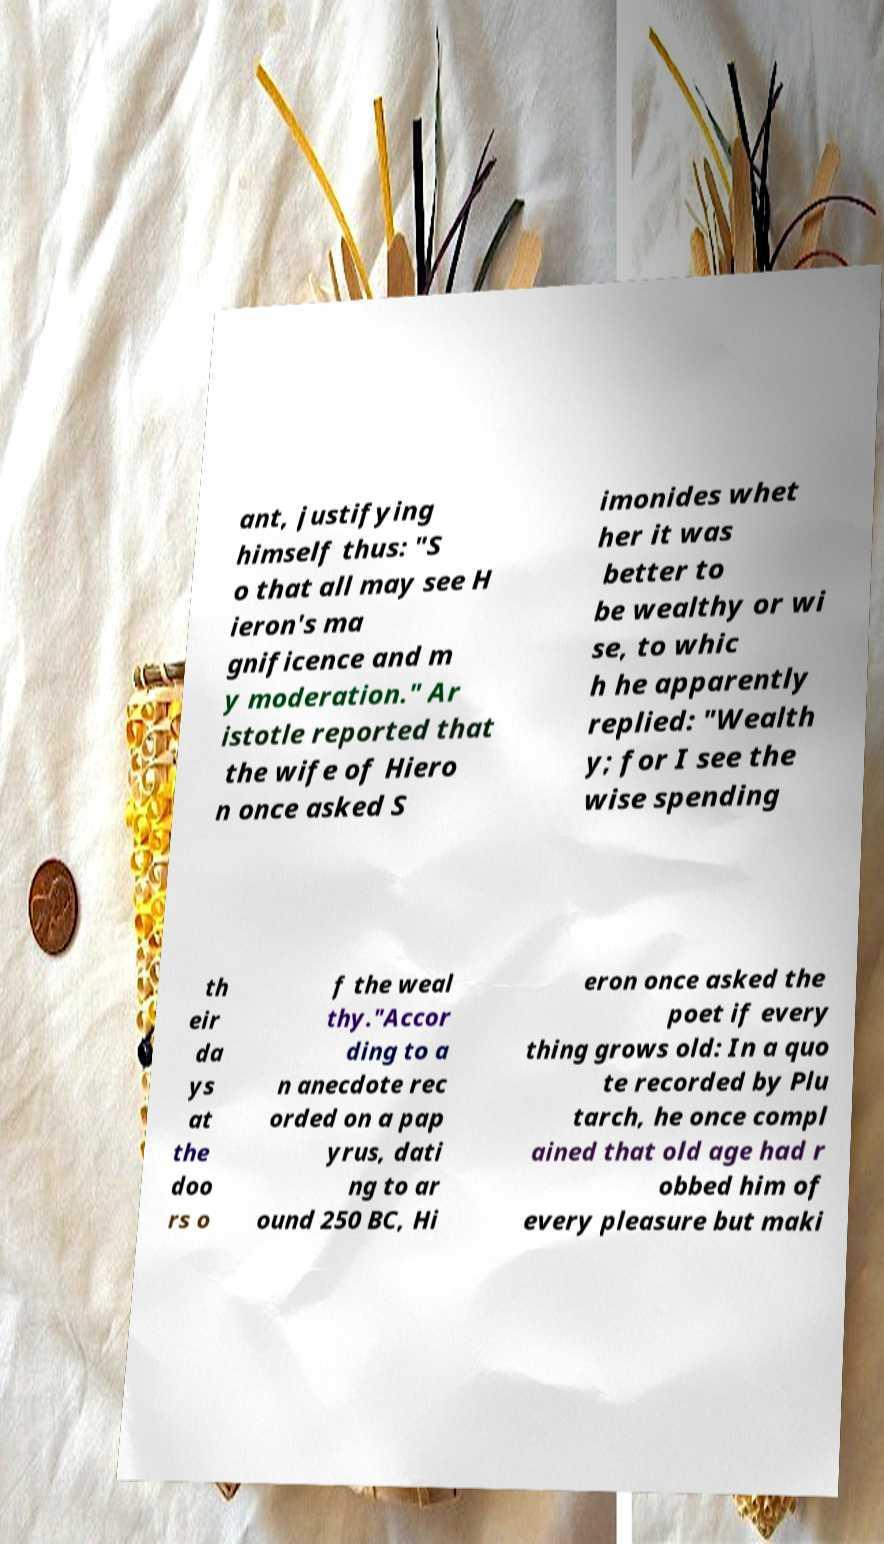There's text embedded in this image that I need extracted. Can you transcribe it verbatim? ant, justifying himself thus: "S o that all may see H ieron's ma gnificence and m y moderation." Ar istotle reported that the wife of Hiero n once asked S imonides whet her it was better to be wealthy or wi se, to whic h he apparently replied: "Wealth y; for I see the wise spending th eir da ys at the doo rs o f the weal thy."Accor ding to a n anecdote rec orded on a pap yrus, dati ng to ar ound 250 BC, Hi eron once asked the poet if every thing grows old: In a quo te recorded by Plu tarch, he once compl ained that old age had r obbed him of every pleasure but maki 